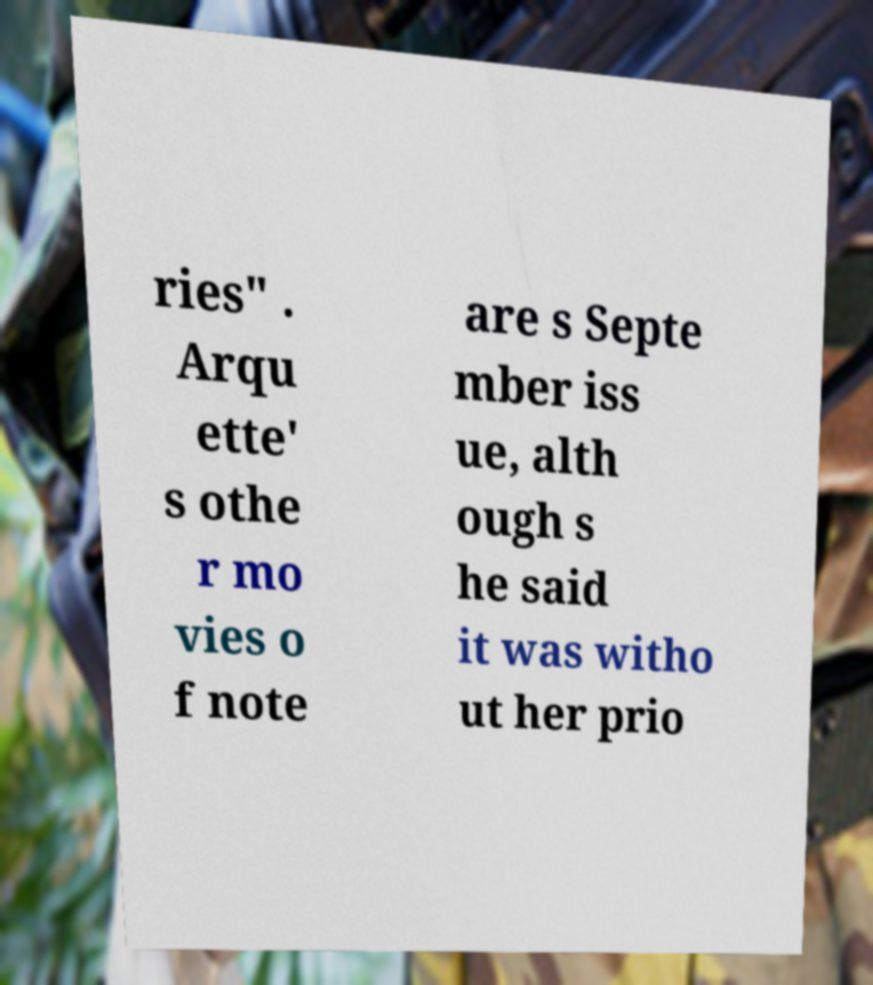Please identify and transcribe the text found in this image. ries" . Arqu ette' s othe r mo vies o f note are s Septe mber iss ue, alth ough s he said it was witho ut her prio 